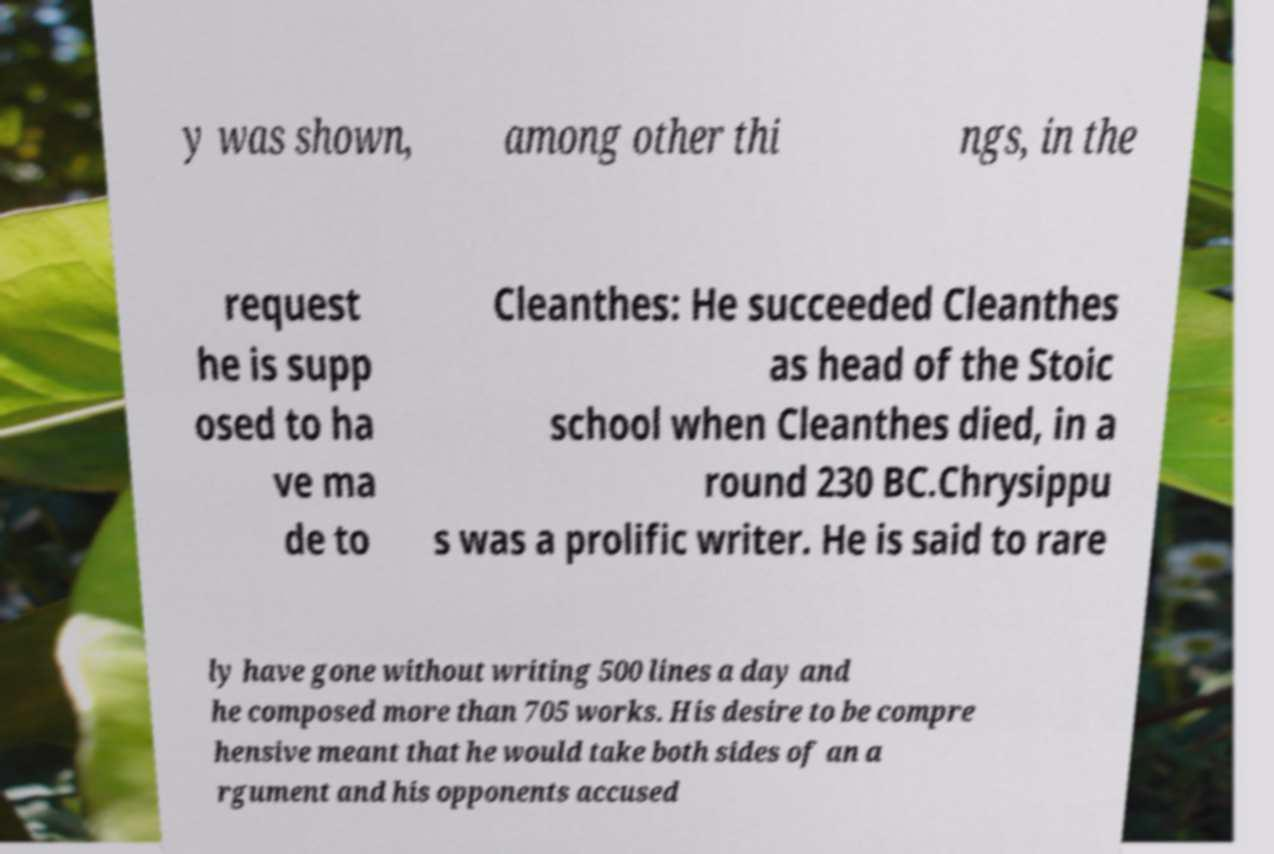Could you assist in decoding the text presented in this image and type it out clearly? y was shown, among other thi ngs, in the request he is supp osed to ha ve ma de to Cleanthes: He succeeded Cleanthes as head of the Stoic school when Cleanthes died, in a round 230 BC.Chrysippu s was a prolific writer. He is said to rare ly have gone without writing 500 lines a day and he composed more than 705 works. His desire to be compre hensive meant that he would take both sides of an a rgument and his opponents accused 